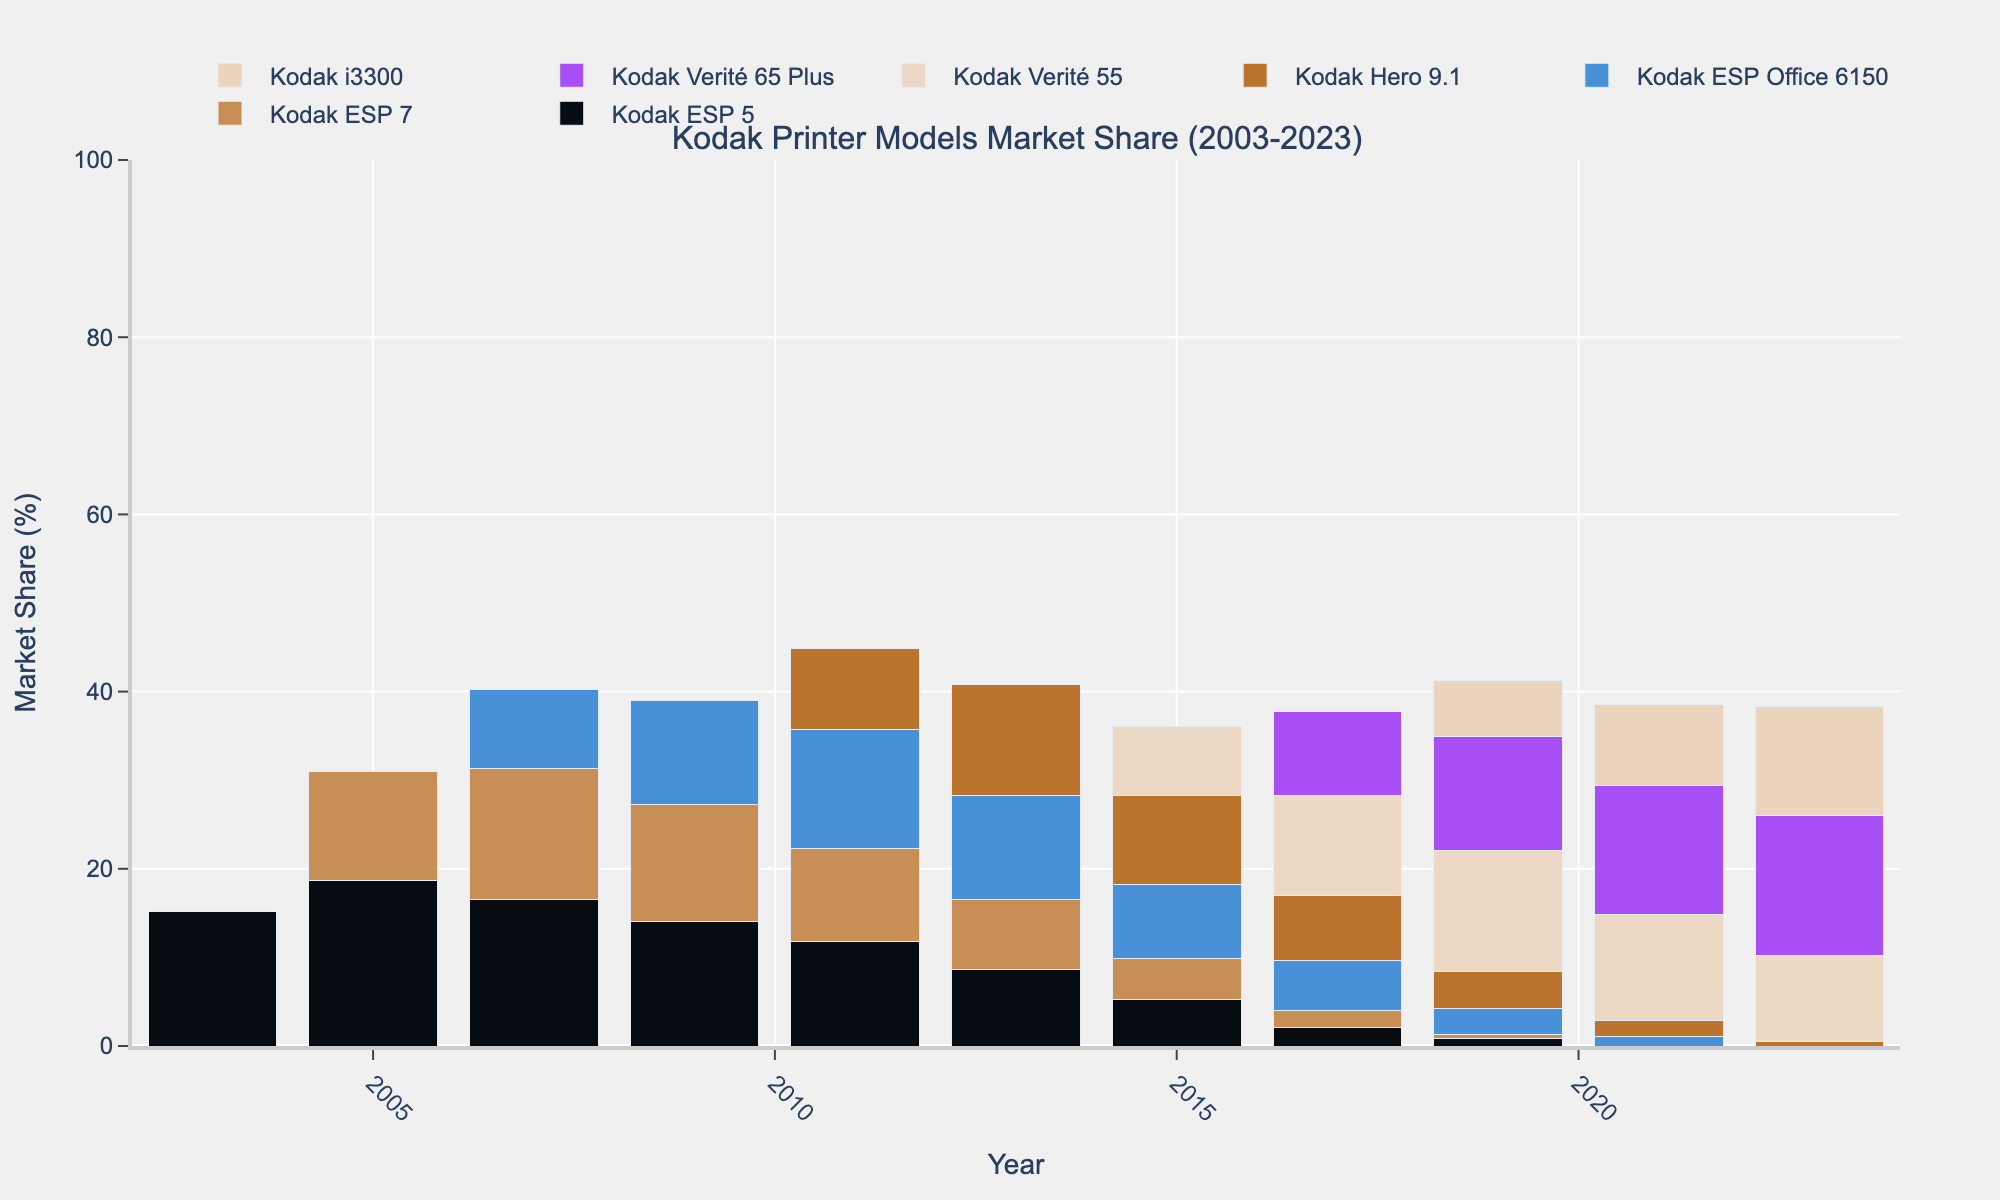Which Kodak printer model had the highest market share in 2003? The only model shown in 2003 is the Kodak ESP 5, which had a market share of 15.2%.
Answer: Kodak ESP 5 Comparing 2011 and 2023, which model's market share increased the most? In 2011, the Kodak Hero 9.1 had a market share of 9.2%, and in 2023, the Kodak Verité 65 Plus had a market share of 15.8%. The net increase for Kodak Verité 65 Plus is the highest among all models.
Answer: Kodak Verité 65 Plus What is the sum of the market shares of Kodak ESP 5 and Kodak ESP 7 in 2011? In 2011, Kodak ESP 5 had a market share of 11.8%, and Kodak ESP 7 had a market share of 10.5%. The sum is 11.8% + 10.5% = 22.3%.
Answer: 22.3% Which year did the Kodak Verité 55 first appear on the market? The Kodak Verité 55 first appears in the data in 2015 with a market share of 7.8%.
Answer: 2015 Between 2007 and 2009, how did the market share of Kodak ESP Office 6150 change? In 2007, Kodak ESP Office 6150 had a market share of 8.9%. In 2009, it increased to 11.7%, showing an increase.
Answer: Increased What is the total market share of all models in the year 2023? By adding up the market shares: Kodak ESP 5=0%, Kodak ESP 7=0%, Kodak ESP Office 6150=0%, Kodak Hero 9.1=0.5%, Kodak Verité 55=9.7%, Kodak Verité 65 Plus=15.8%, Kodak i3300=12.3%. The total is 0 + 0 + 0 + 0.5 + 9.7 + 15.8 + 12.3 = 38.3%.
Answer: 38.3% In what years did Kodak ESP 5 have a declining market share compared to the previous data point? Starting from 2003: 2003 (15.2%), 2005 (18.7%), 2007 (16.5%), 2009 (14.1%), 2011 (11.8%), 2013 (8.6%), 2015 (5.2%), 2017 (2.1%), 2019 (0.8%), showing declines in 2007, 2009, 2011, 2013, 2015, 2017, and 2019.
Answer: 2007, 2009, 2011, 2013, 2015, 2017, 2019 Which model had the largest increase in market share from 2019 to 2021? The market shares increased as follows: Kodak Verité 65 Plus (12.8% to 14.6%, increase of 1.8%), Kodak i3300 (6.4% to 9.2%, increase of 2.8%). Kodak i3300 saw the largest increase.
Answer: Kodak i3300 